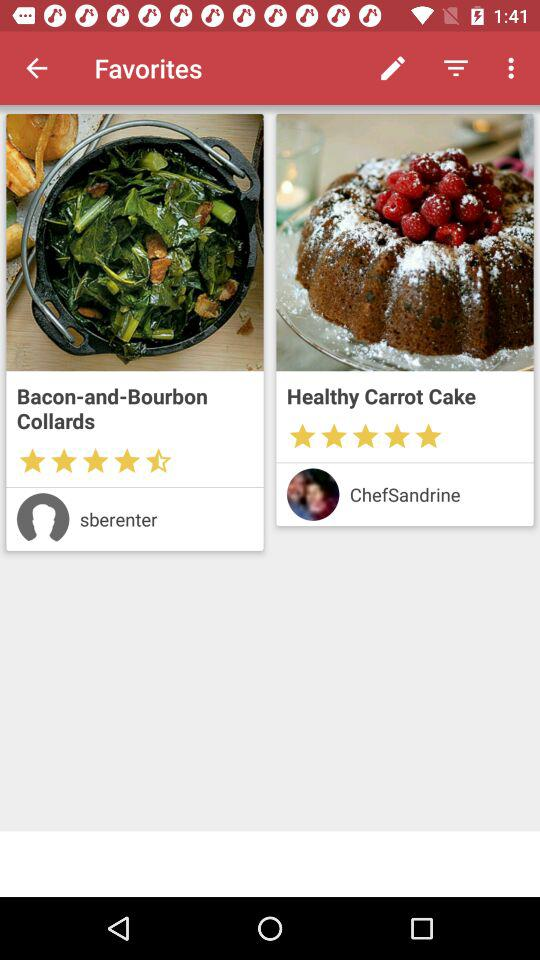What is the rating of the "Healthy Carrot Cake"? The rating is 5 stars. 